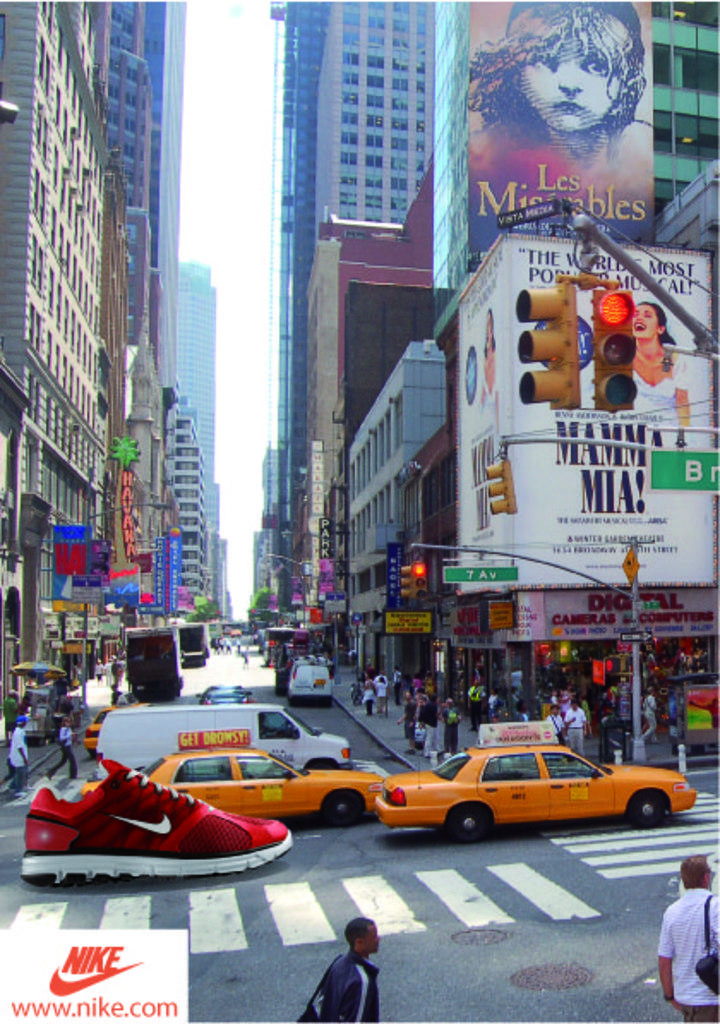Could you give a brief overview of what you see in this image? In this image I can see few vehicles and red color shoe is on the road. Back Side I can see signboard,traffic signal,poles and few people are around. I can see buildings and windows. Banner is attached to the wall. 